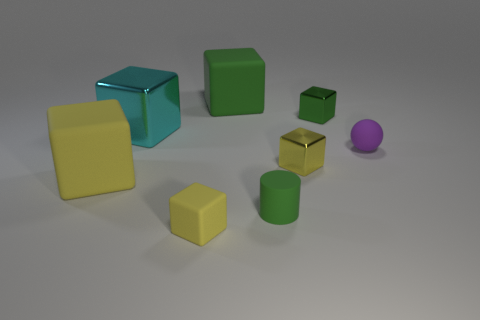Subtract all brown cylinders. How many yellow blocks are left? 3 Subtract all green shiny blocks. How many blocks are left? 5 Subtract all green blocks. How many blocks are left? 4 Subtract all blue cubes. Subtract all gray cylinders. How many cubes are left? 6 Add 2 large yellow objects. How many objects exist? 10 Subtract all balls. How many objects are left? 7 Add 3 yellow metallic cubes. How many yellow metallic cubes exist? 4 Subtract 0 purple cylinders. How many objects are left? 8 Subtract all small cyan metal things. Subtract all purple things. How many objects are left? 7 Add 2 big yellow objects. How many big yellow objects are left? 3 